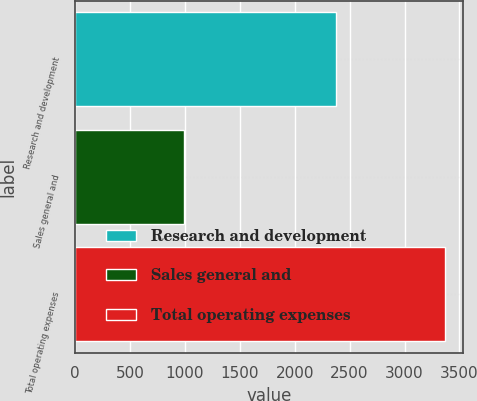Convert chart. <chart><loc_0><loc_0><loc_500><loc_500><bar_chart><fcel>Research and development<fcel>Sales general and<fcel>Total operating expenses<nl><fcel>2376<fcel>991<fcel>3367<nl></chart> 